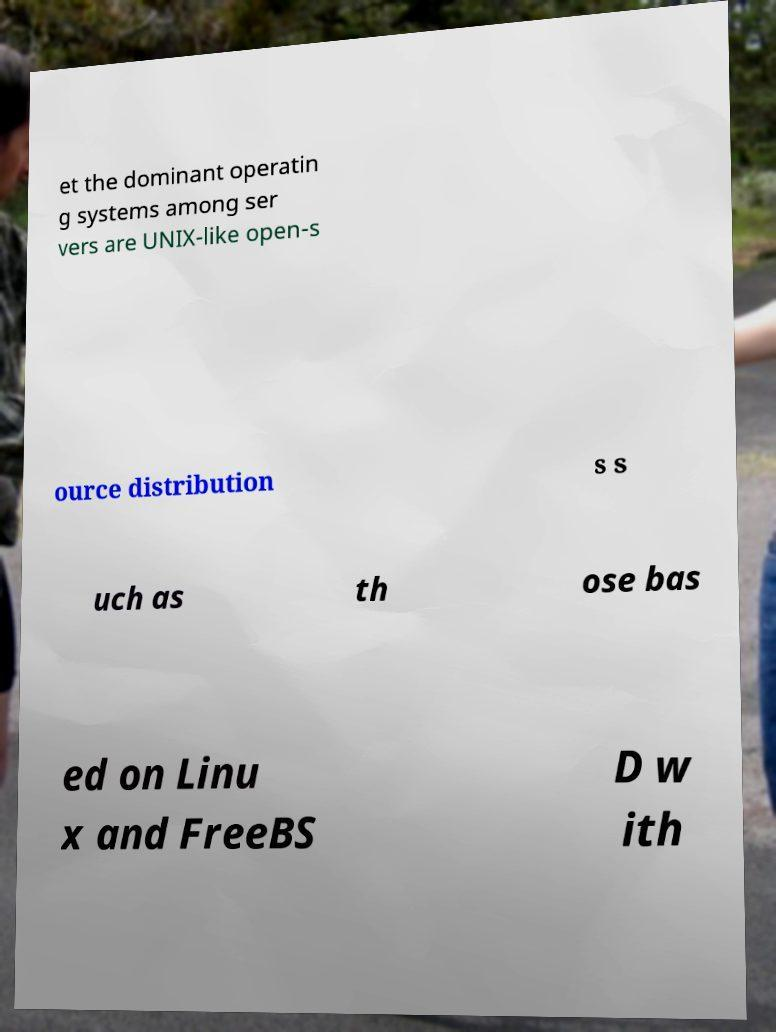Can you accurately transcribe the text from the provided image for me? et the dominant operatin g systems among ser vers are UNIX-like open-s ource distribution s s uch as th ose bas ed on Linu x and FreeBS D w ith 